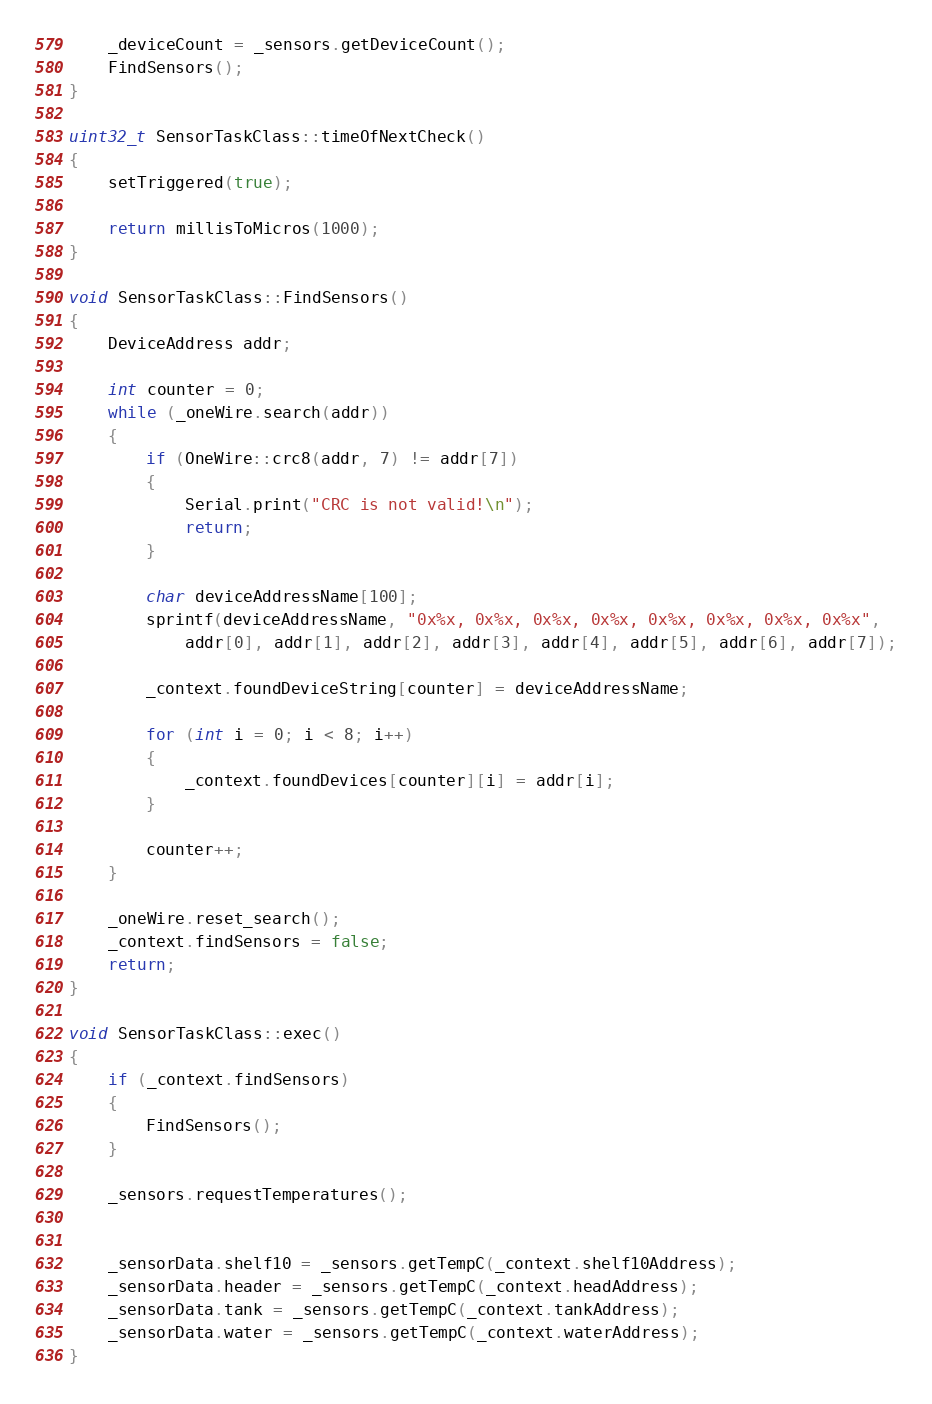<code> <loc_0><loc_0><loc_500><loc_500><_C++_>	_deviceCount = _sensors.getDeviceCount();
	FindSensors();
}

uint32_t SensorTaskClass::timeOfNextCheck()
{
	setTriggered(true);

	return millisToMicros(1000);
}

void SensorTaskClass::FindSensors()
{
	DeviceAddress addr;

	int counter = 0;
	while (_oneWire.search(addr))
	{
		if (OneWire::crc8(addr, 7) != addr[7])
		{
			Serial.print("CRC is not valid!\n");
			return;
		}

		char deviceAddressName[100];
		sprintf(deviceAddressName, "0x%x, 0x%x, 0x%x, 0x%x, 0x%x, 0x%x, 0x%x, 0x%x", 
			addr[0], addr[1], addr[2], addr[3], addr[4], addr[5], addr[6], addr[7]);
		
		_context.foundDeviceString[counter] = deviceAddressName;
		
		for (int i = 0; i < 8; i++)
		{
			_context.foundDevices[counter][i] = addr[i];
		}

		counter++;
	}

	_oneWire.reset_search();
	_context.findSensors = false;
	return;
}

void SensorTaskClass::exec()
{
	if (_context.findSensors)
	{
		FindSensors();
	}

	_sensors.requestTemperatures();


	_sensorData.shelf10 = _sensors.getTempC(_context.shelf10Address);
	_sensorData.header = _sensors.getTempC(_context.headAddress);
	_sensorData.tank = _sensors.getTempC(_context.tankAddress);
	_sensorData.water = _sensors.getTempC(_context.waterAddress);
}
</code> 